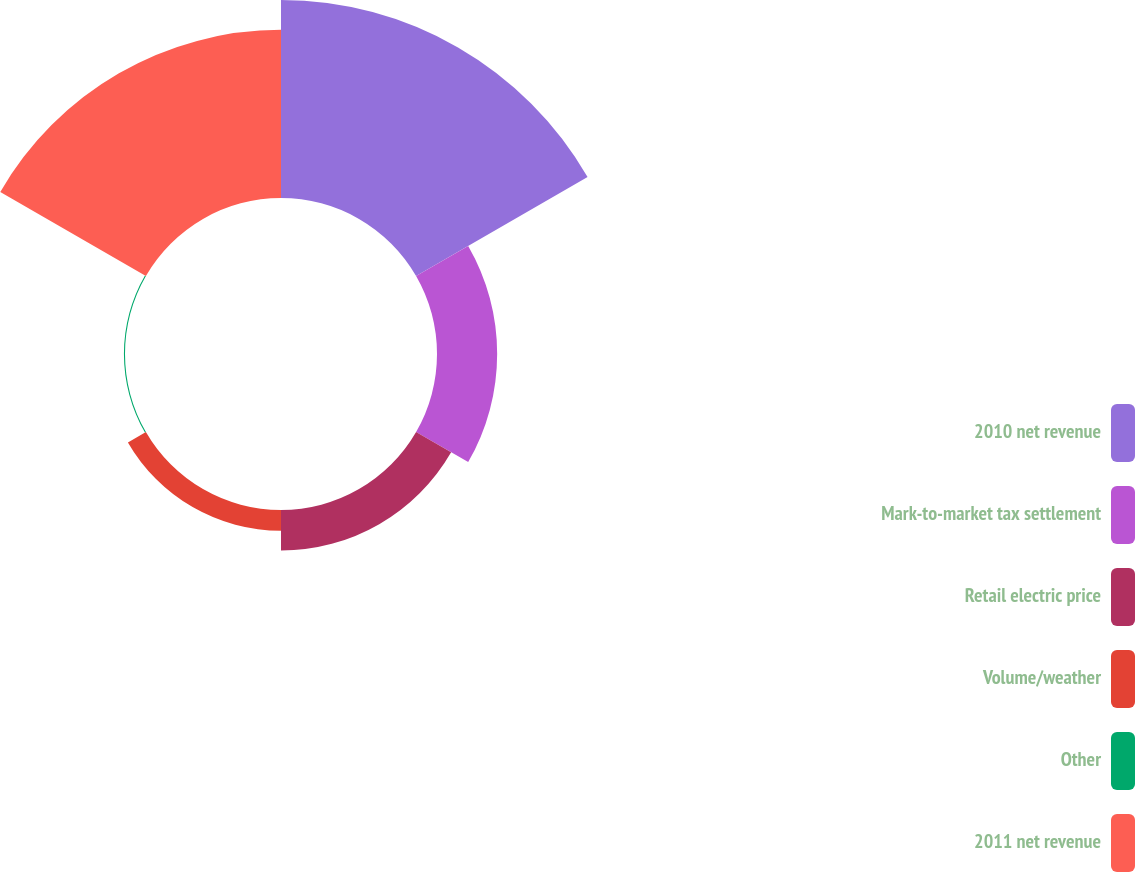Convert chart. <chart><loc_0><loc_0><loc_500><loc_500><pie_chart><fcel>2010 net revenue<fcel>Mark-to-market tax settlement<fcel>Retail electric price<fcel>Volume/weather<fcel>Other<fcel>2011 net revenue<nl><fcel>40.52%<fcel>12.31%<fcel>8.28%<fcel>4.25%<fcel>0.22%<fcel>34.41%<nl></chart> 